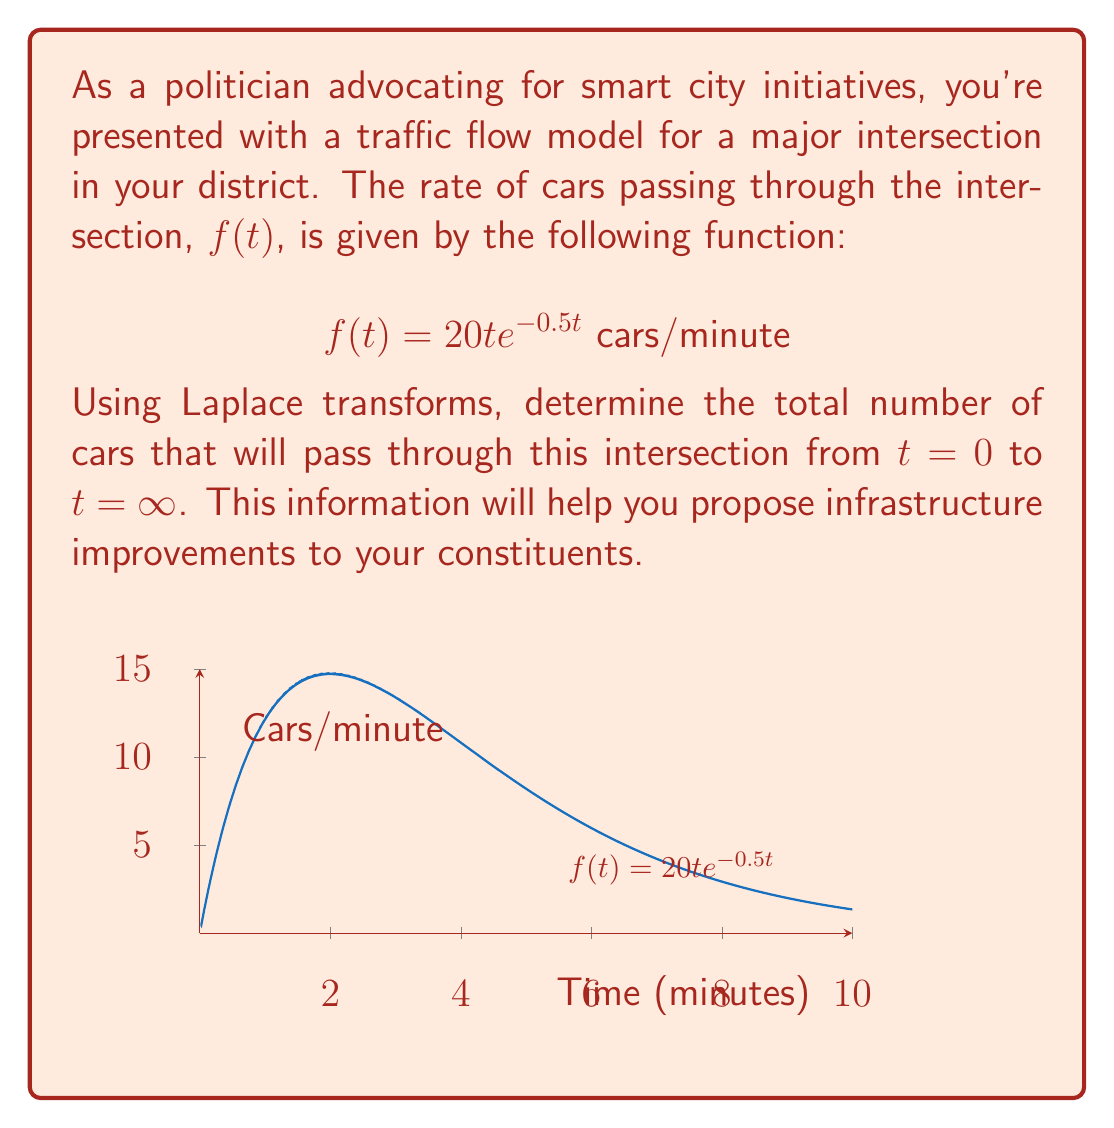Solve this math problem. Let's approach this step-by-step using Laplace transforms:

1) The Laplace transform of $f(t)$ is given by:
   $$F(s) = \mathcal{L}\{f(t)\} = \int_0^\infty f(t)e^{-st}dt$$

2) We need to find $F(0)$, which represents the total area under the curve $f(t)$ from 0 to $\infty$.

3) The Laplace transform of $te^{-at}$ is known to be:
   $$\mathcal{L}\{te^{-at}\} = \frac{1}{(s+a)^2}$$

4) In our case, $a=0.5$ and we have a factor of 20, so:
   $$F(s) = \frac{20}{(s+0.5)^2}$$

5) To find the total number of cars, we evaluate $F(0)$:
   $$F(0) = \frac{20}{(0+0.5)^2} = \frac{20}{0.25} = 80$$

6) Therefore, the total number of cars passing through the intersection from $t=0$ to $t=\infty$ is 80.
Answer: 80 cars 